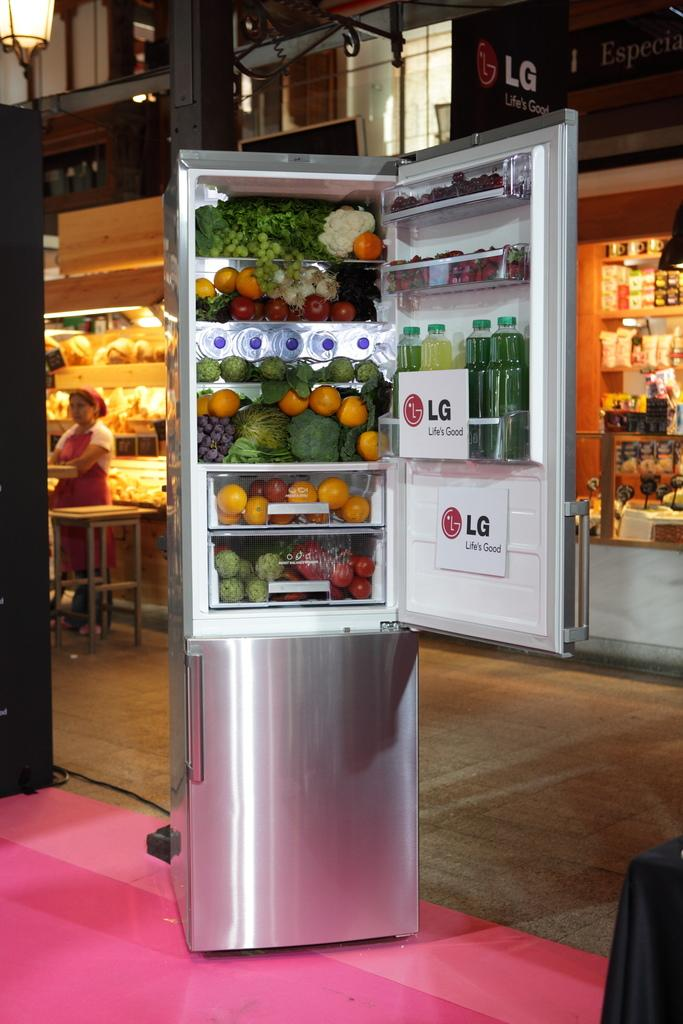<image>
Present a compact description of the photo's key features. A freestanding stainless steel Lg fridge displayed full of food. 